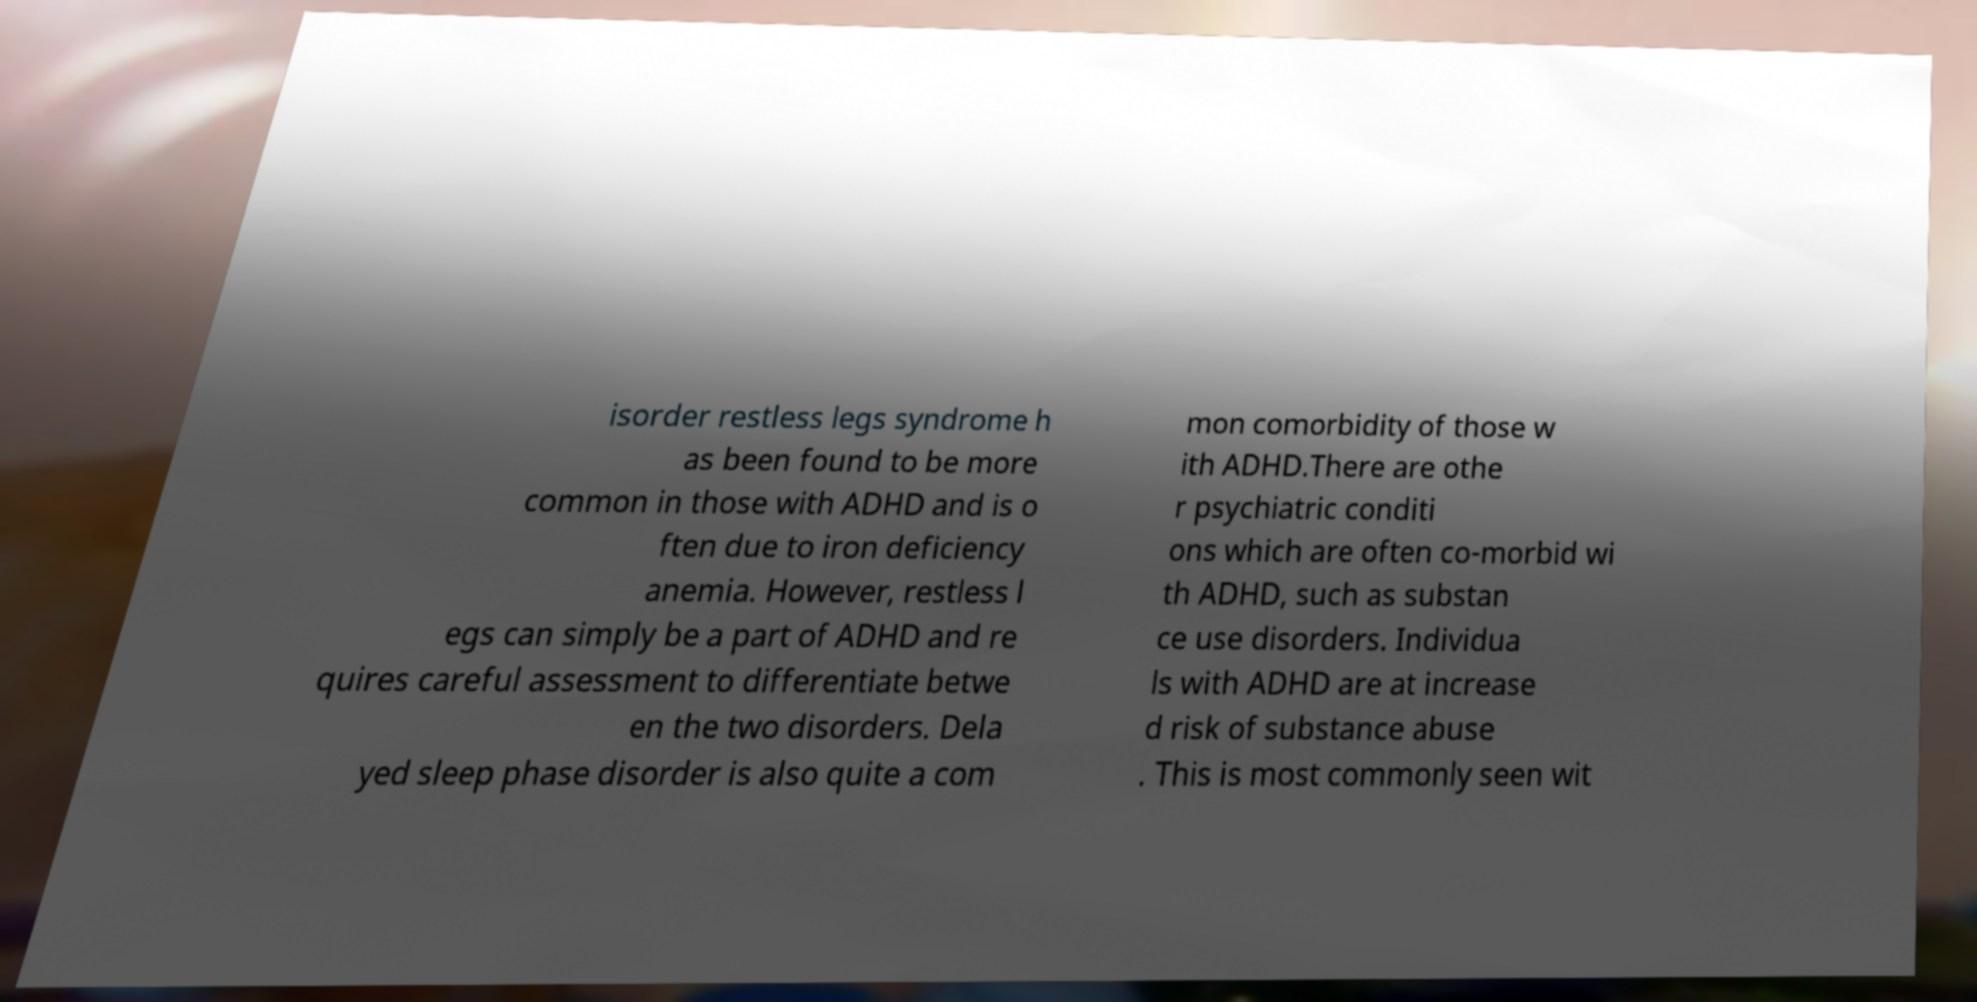For documentation purposes, I need the text within this image transcribed. Could you provide that? isorder restless legs syndrome h as been found to be more common in those with ADHD and is o ften due to iron deficiency anemia. However, restless l egs can simply be a part of ADHD and re quires careful assessment to differentiate betwe en the two disorders. Dela yed sleep phase disorder is also quite a com mon comorbidity of those w ith ADHD.There are othe r psychiatric conditi ons which are often co-morbid wi th ADHD, such as substan ce use disorders. Individua ls with ADHD are at increase d risk of substance abuse . This is most commonly seen wit 